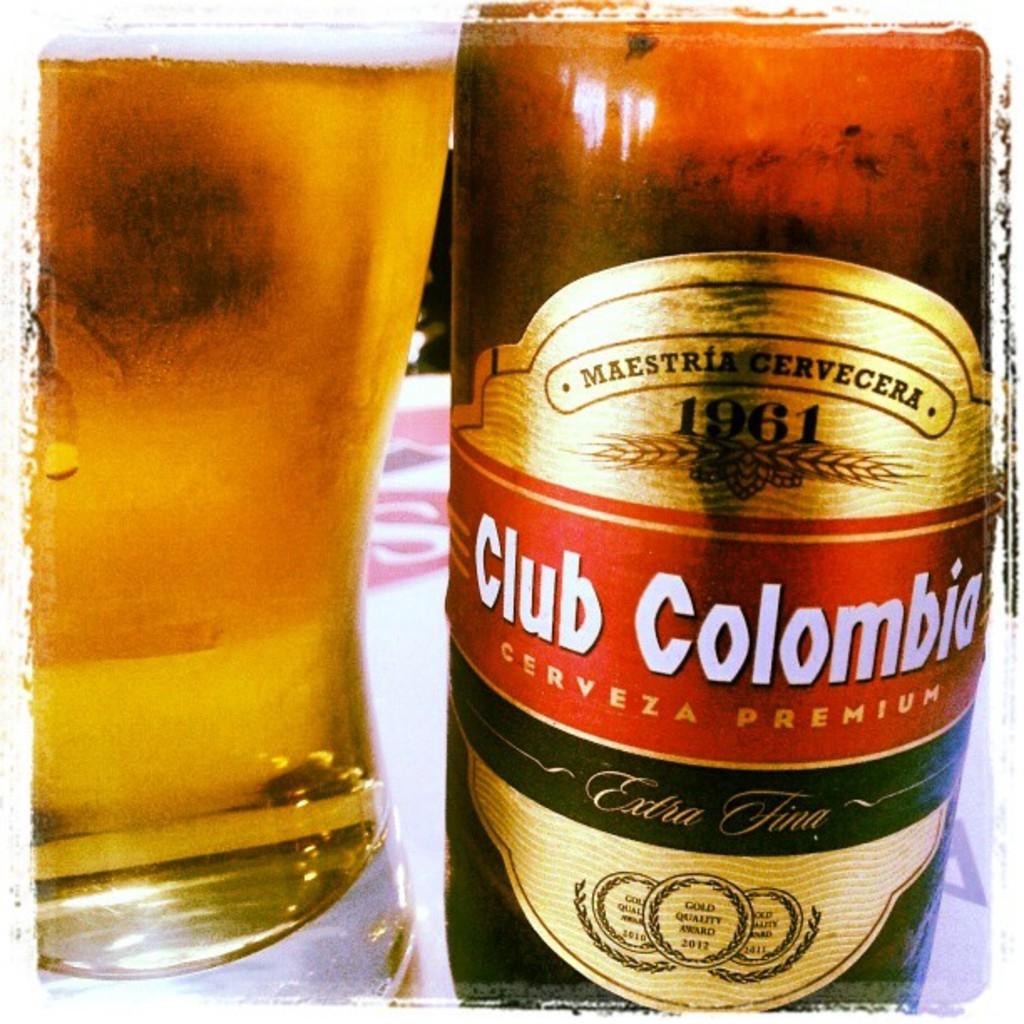What year was this drink made?
Give a very brief answer. 1961. What is the name of this beer?
Ensure brevity in your answer.  Club colombia. 